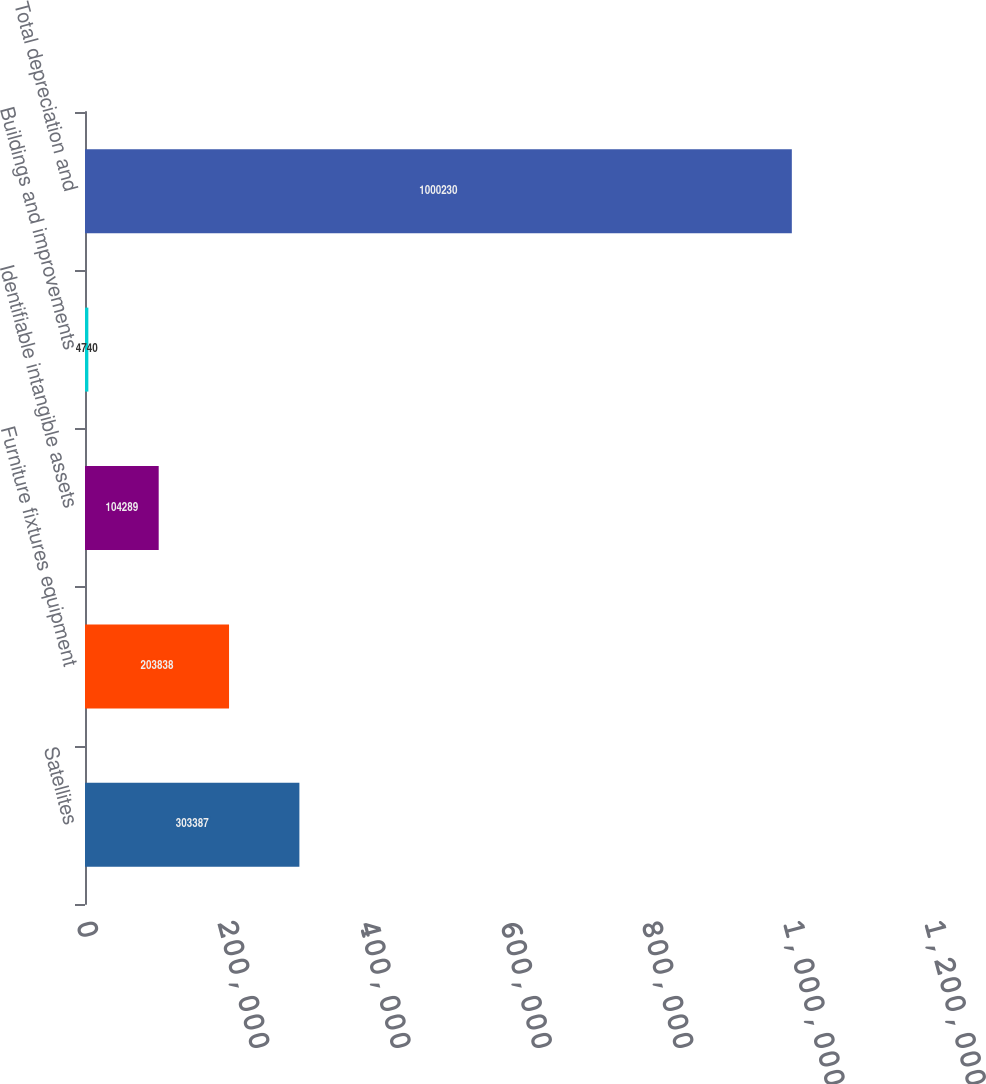Convert chart to OTSL. <chart><loc_0><loc_0><loc_500><loc_500><bar_chart><fcel>Satellites<fcel>Furniture fixtures equipment<fcel>Identifiable intangible assets<fcel>Buildings and improvements<fcel>Total depreciation and<nl><fcel>303387<fcel>203838<fcel>104289<fcel>4740<fcel>1.00023e+06<nl></chart> 